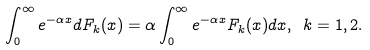Convert formula to latex. <formula><loc_0><loc_0><loc_500><loc_500>\int _ { 0 } ^ { \infty } e ^ { - \alpha x } d F _ { k } ( x ) = \alpha \int _ { 0 } ^ { \infty } e ^ { - \alpha x } F _ { k } ( x ) d x , \ k = 1 , 2 .</formula> 